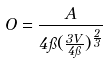Convert formula to latex. <formula><loc_0><loc_0><loc_500><loc_500>O = \frac { A } { 4 \pi ( \frac { 3 V } { 4 \pi } ) ^ { \frac { 2 } { 3 } } }</formula> 